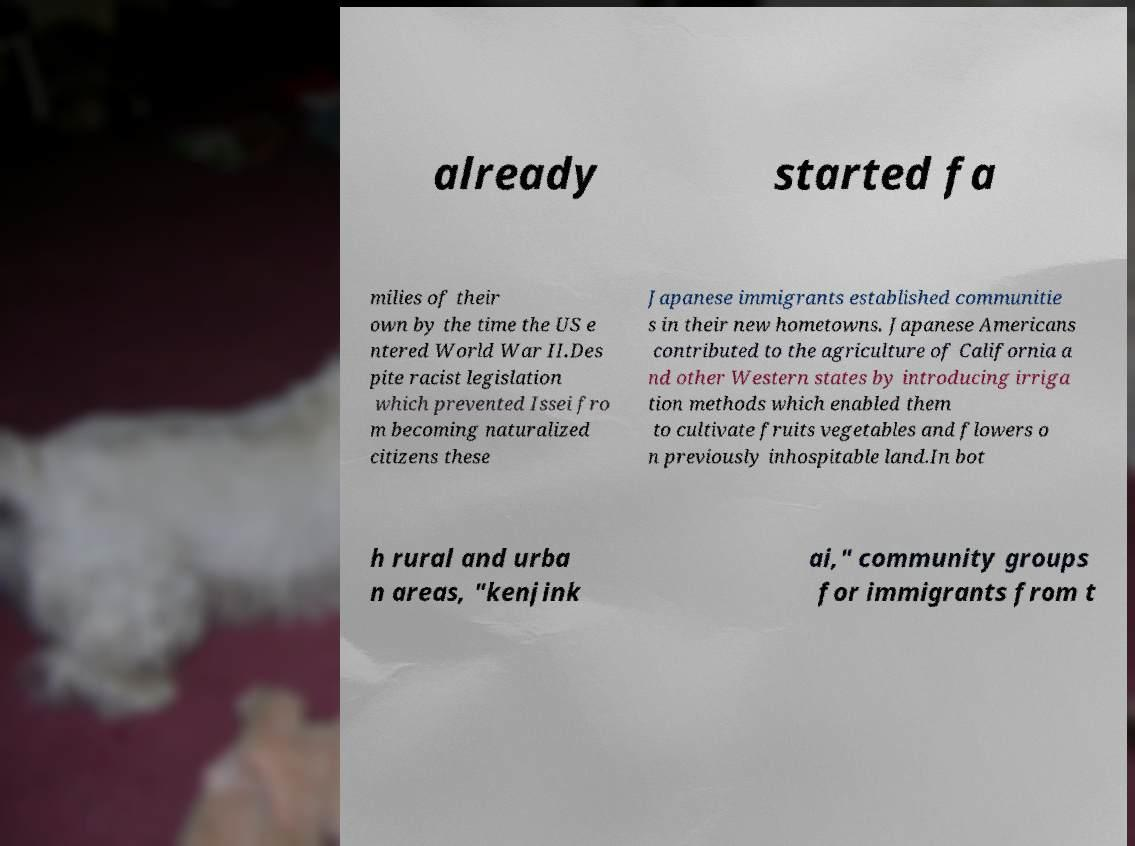Please identify and transcribe the text found in this image. already started fa milies of their own by the time the US e ntered World War II.Des pite racist legislation which prevented Issei fro m becoming naturalized citizens these Japanese immigrants established communitie s in their new hometowns. Japanese Americans contributed to the agriculture of California a nd other Western states by introducing irriga tion methods which enabled them to cultivate fruits vegetables and flowers o n previously inhospitable land.In bot h rural and urba n areas, "kenjink ai," community groups for immigrants from t 